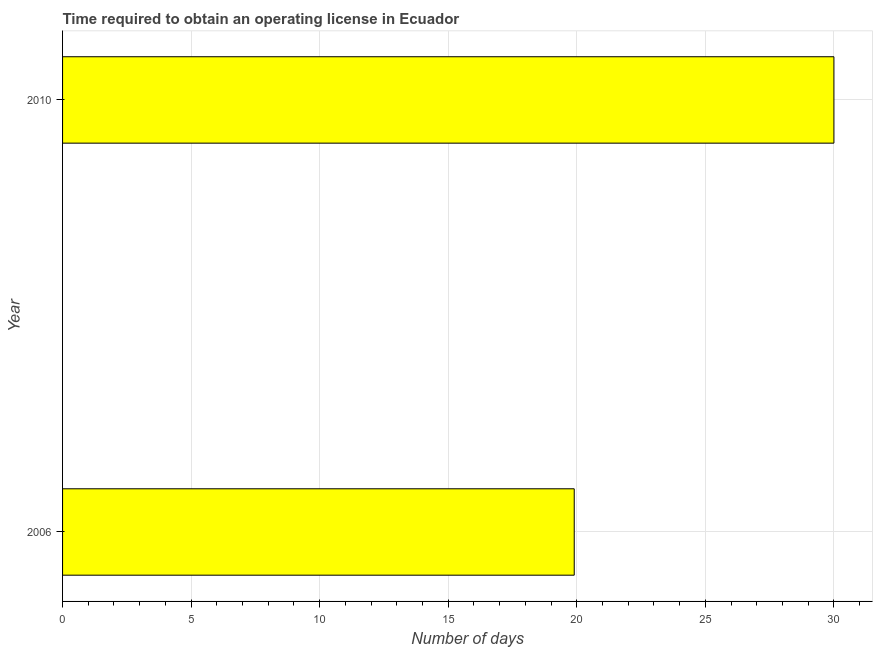Does the graph contain any zero values?
Make the answer very short. No. What is the title of the graph?
Offer a terse response. Time required to obtain an operating license in Ecuador. What is the label or title of the X-axis?
Give a very brief answer. Number of days. What is the label or title of the Y-axis?
Provide a succinct answer. Year. What is the number of days to obtain operating license in 2006?
Offer a terse response. 19.9. Across all years, what is the maximum number of days to obtain operating license?
Your answer should be compact. 30. Across all years, what is the minimum number of days to obtain operating license?
Your answer should be very brief. 19.9. In which year was the number of days to obtain operating license minimum?
Provide a succinct answer. 2006. What is the sum of the number of days to obtain operating license?
Your answer should be very brief. 49.9. What is the difference between the number of days to obtain operating license in 2006 and 2010?
Offer a terse response. -10.1. What is the average number of days to obtain operating license per year?
Ensure brevity in your answer.  24.95. What is the median number of days to obtain operating license?
Your answer should be compact. 24.95. In how many years, is the number of days to obtain operating license greater than 7 days?
Offer a terse response. 2. Do a majority of the years between 2006 and 2010 (inclusive) have number of days to obtain operating license greater than 5 days?
Your answer should be compact. Yes. What is the ratio of the number of days to obtain operating license in 2006 to that in 2010?
Your response must be concise. 0.66. How many bars are there?
Your response must be concise. 2. How many years are there in the graph?
Offer a very short reply. 2. What is the difference between two consecutive major ticks on the X-axis?
Ensure brevity in your answer.  5. Are the values on the major ticks of X-axis written in scientific E-notation?
Provide a short and direct response. No. What is the Number of days in 2010?
Ensure brevity in your answer.  30. What is the difference between the Number of days in 2006 and 2010?
Your response must be concise. -10.1. What is the ratio of the Number of days in 2006 to that in 2010?
Your answer should be very brief. 0.66. 